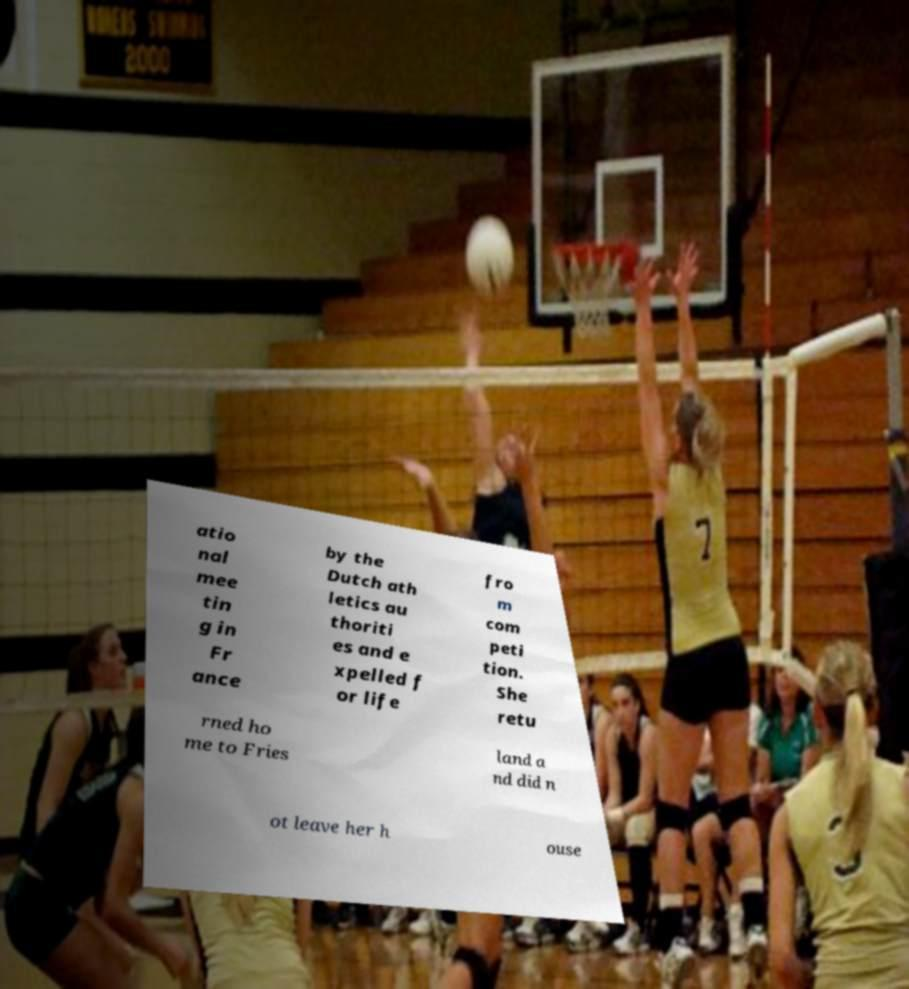Can you read and provide the text displayed in the image?This photo seems to have some interesting text. Can you extract and type it out for me? atio nal mee tin g in Fr ance by the Dutch ath letics au thoriti es and e xpelled f or life fro m com peti tion. She retu rned ho me to Fries land a nd did n ot leave her h ouse 